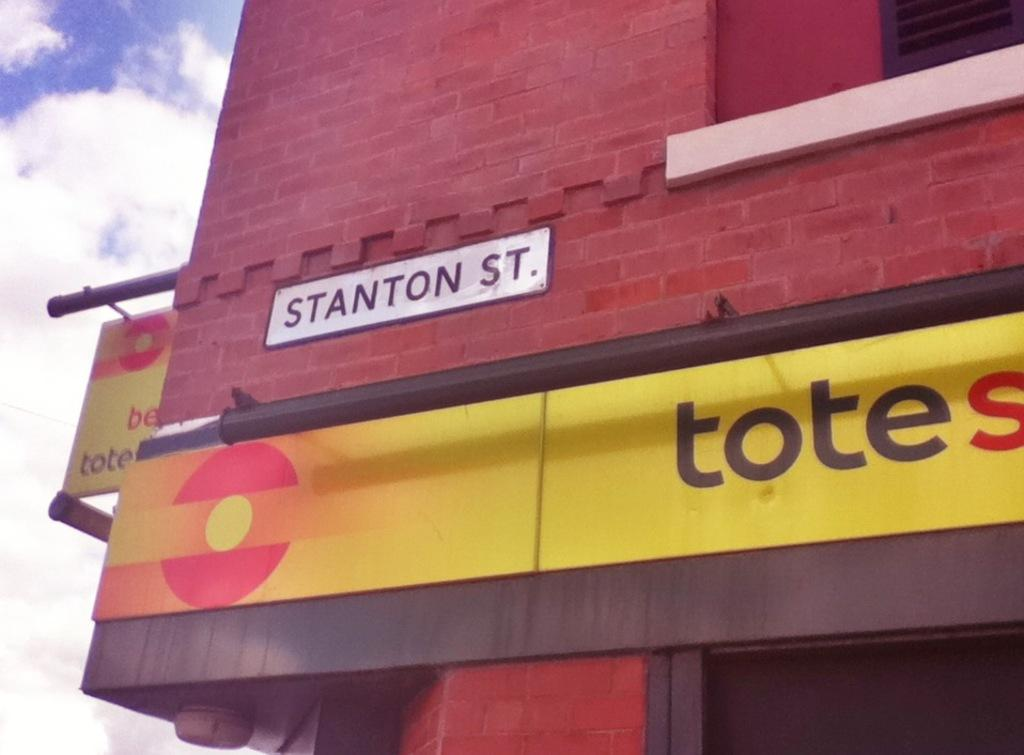What is on the building in the image? There are hoardings on the building in the image. What can be seen in the sky in the image? There are clouds visible in the image. How many snakes are slithering on the hoardings in the image? There are no snakes present in the image; it only features hoardings on the building. What question is being asked by the clouds in the image? The clouds in the image are not capable of asking questions, as they are a natural phenomenon and not sentient beings. 